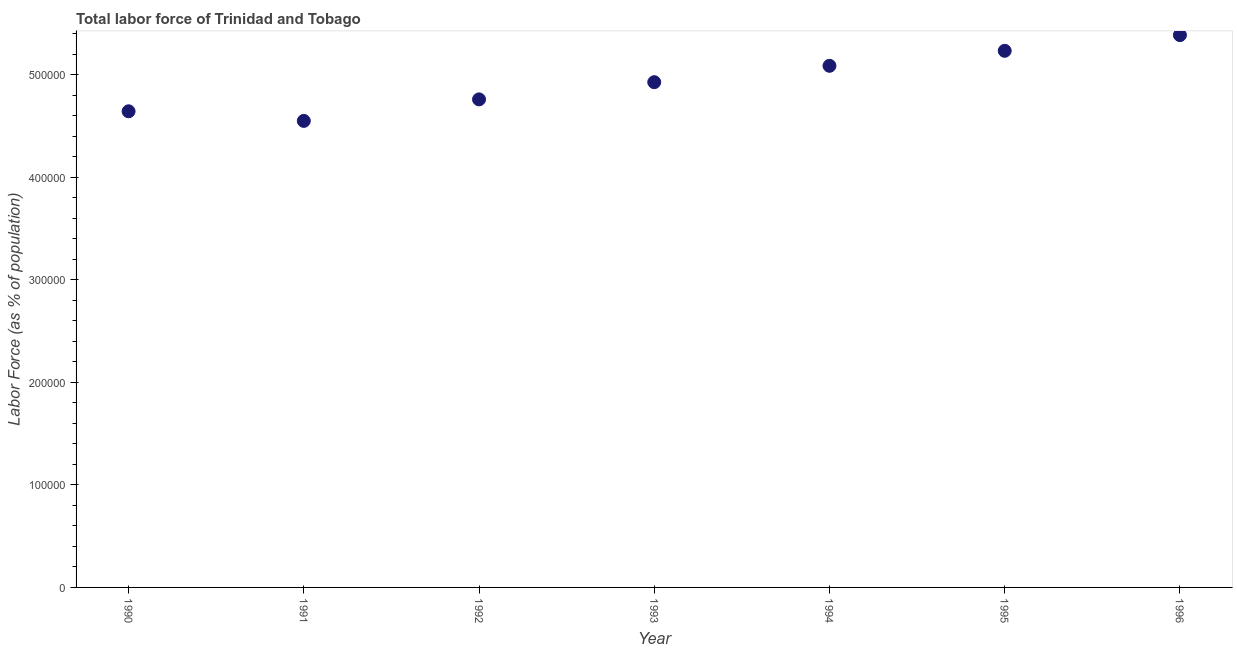What is the total labor force in 1994?
Your answer should be very brief. 5.09e+05. Across all years, what is the maximum total labor force?
Make the answer very short. 5.38e+05. Across all years, what is the minimum total labor force?
Your answer should be very brief. 4.55e+05. What is the sum of the total labor force?
Offer a terse response. 3.46e+06. What is the difference between the total labor force in 1992 and 1996?
Your response must be concise. -6.27e+04. What is the average total labor force per year?
Give a very brief answer. 4.94e+05. What is the median total labor force?
Offer a terse response. 4.93e+05. In how many years, is the total labor force greater than 400000 %?
Your response must be concise. 7. What is the ratio of the total labor force in 1993 to that in 1994?
Ensure brevity in your answer.  0.97. Is the total labor force in 1991 less than that in 1994?
Offer a terse response. Yes. What is the difference between the highest and the second highest total labor force?
Keep it short and to the point. 1.53e+04. Is the sum of the total labor force in 1993 and 1994 greater than the maximum total labor force across all years?
Your answer should be compact. Yes. What is the difference between the highest and the lowest total labor force?
Your response must be concise. 8.36e+04. In how many years, is the total labor force greater than the average total labor force taken over all years?
Your response must be concise. 3. Does the total labor force monotonically increase over the years?
Your answer should be compact. No. How many dotlines are there?
Give a very brief answer. 1. How many years are there in the graph?
Keep it short and to the point. 7. Are the values on the major ticks of Y-axis written in scientific E-notation?
Make the answer very short. No. Does the graph contain grids?
Provide a short and direct response. No. What is the title of the graph?
Make the answer very short. Total labor force of Trinidad and Tobago. What is the label or title of the X-axis?
Give a very brief answer. Year. What is the label or title of the Y-axis?
Ensure brevity in your answer.  Labor Force (as % of population). What is the Labor Force (as % of population) in 1990?
Provide a succinct answer. 4.64e+05. What is the Labor Force (as % of population) in 1991?
Offer a very short reply. 4.55e+05. What is the Labor Force (as % of population) in 1992?
Your answer should be compact. 4.76e+05. What is the Labor Force (as % of population) in 1993?
Give a very brief answer. 4.93e+05. What is the Labor Force (as % of population) in 1994?
Provide a succinct answer. 5.09e+05. What is the Labor Force (as % of population) in 1995?
Your response must be concise. 5.23e+05. What is the Labor Force (as % of population) in 1996?
Provide a succinct answer. 5.38e+05. What is the difference between the Labor Force (as % of population) in 1990 and 1991?
Offer a terse response. 9366. What is the difference between the Labor Force (as % of population) in 1990 and 1992?
Make the answer very short. -1.16e+04. What is the difference between the Labor Force (as % of population) in 1990 and 1993?
Keep it short and to the point. -2.84e+04. What is the difference between the Labor Force (as % of population) in 1990 and 1994?
Make the answer very short. -4.43e+04. What is the difference between the Labor Force (as % of population) in 1990 and 1995?
Ensure brevity in your answer.  -5.90e+04. What is the difference between the Labor Force (as % of population) in 1990 and 1996?
Your answer should be compact. -7.43e+04. What is the difference between the Labor Force (as % of population) in 1991 and 1992?
Make the answer very short. -2.10e+04. What is the difference between the Labor Force (as % of population) in 1991 and 1993?
Provide a succinct answer. -3.77e+04. What is the difference between the Labor Force (as % of population) in 1991 and 1994?
Ensure brevity in your answer.  -5.37e+04. What is the difference between the Labor Force (as % of population) in 1991 and 1995?
Provide a succinct answer. -6.83e+04. What is the difference between the Labor Force (as % of population) in 1991 and 1996?
Your response must be concise. -8.36e+04. What is the difference between the Labor Force (as % of population) in 1992 and 1993?
Your answer should be very brief. -1.68e+04. What is the difference between the Labor Force (as % of population) in 1992 and 1994?
Your answer should be compact. -3.27e+04. What is the difference between the Labor Force (as % of population) in 1992 and 1995?
Provide a succinct answer. -4.74e+04. What is the difference between the Labor Force (as % of population) in 1992 and 1996?
Offer a very short reply. -6.27e+04. What is the difference between the Labor Force (as % of population) in 1993 and 1994?
Provide a succinct answer. -1.60e+04. What is the difference between the Labor Force (as % of population) in 1993 and 1995?
Offer a very short reply. -3.06e+04. What is the difference between the Labor Force (as % of population) in 1993 and 1996?
Your response must be concise. -4.59e+04. What is the difference between the Labor Force (as % of population) in 1994 and 1995?
Offer a terse response. -1.46e+04. What is the difference between the Labor Force (as % of population) in 1994 and 1996?
Provide a succinct answer. -2.99e+04. What is the difference between the Labor Force (as % of population) in 1995 and 1996?
Keep it short and to the point. -1.53e+04. What is the ratio of the Labor Force (as % of population) in 1990 to that in 1993?
Offer a terse response. 0.94. What is the ratio of the Labor Force (as % of population) in 1990 to that in 1994?
Make the answer very short. 0.91. What is the ratio of the Labor Force (as % of population) in 1990 to that in 1995?
Keep it short and to the point. 0.89. What is the ratio of the Labor Force (as % of population) in 1990 to that in 1996?
Keep it short and to the point. 0.86. What is the ratio of the Labor Force (as % of population) in 1991 to that in 1992?
Provide a succinct answer. 0.96. What is the ratio of the Labor Force (as % of population) in 1991 to that in 1993?
Give a very brief answer. 0.92. What is the ratio of the Labor Force (as % of population) in 1991 to that in 1994?
Offer a very short reply. 0.89. What is the ratio of the Labor Force (as % of population) in 1991 to that in 1995?
Offer a terse response. 0.87. What is the ratio of the Labor Force (as % of population) in 1991 to that in 1996?
Your response must be concise. 0.84. What is the ratio of the Labor Force (as % of population) in 1992 to that in 1994?
Give a very brief answer. 0.94. What is the ratio of the Labor Force (as % of population) in 1992 to that in 1995?
Offer a terse response. 0.91. What is the ratio of the Labor Force (as % of population) in 1992 to that in 1996?
Offer a terse response. 0.88. What is the ratio of the Labor Force (as % of population) in 1993 to that in 1994?
Keep it short and to the point. 0.97. What is the ratio of the Labor Force (as % of population) in 1993 to that in 1995?
Your answer should be compact. 0.94. What is the ratio of the Labor Force (as % of population) in 1993 to that in 1996?
Offer a very short reply. 0.92. What is the ratio of the Labor Force (as % of population) in 1994 to that in 1995?
Offer a very short reply. 0.97. What is the ratio of the Labor Force (as % of population) in 1994 to that in 1996?
Make the answer very short. 0.94. 